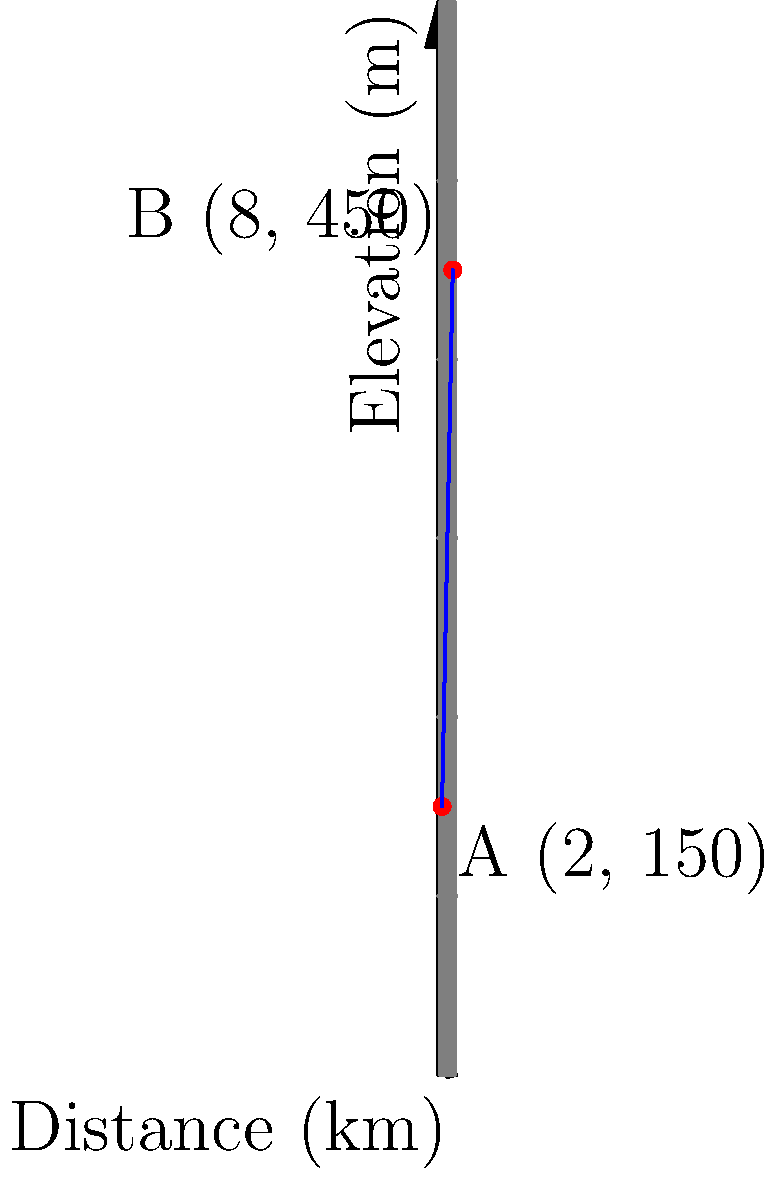During your creek hiking adventure in Nebraska, you come across a particularly challenging trail section. The trail starts at point A (2 km, 150 m) and ends at point B (8 km, 450 m), where the first coordinate represents the distance along the creek, and the second coordinate represents the elevation. What is the slope of this trail section? To find the slope of the trail section, we'll use the slope formula:

$$ \text{Slope} = \frac{\text{Change in y}}{\text{Change in x}} = \frac{y_2 - y_1}{x_2 - x_1} $$

Where $(x_1, y_1)$ is the starting point A, and $(x_2, y_2)$ is the ending point B.

Step 1: Identify the coordinates
Point A: $(x_1, y_1) = (2, 150)$
Point B: $(x_2, y_2) = (8, 450)$

Step 2: Calculate the change in y (elevation)
$\Delta y = y_2 - y_1 = 450 - 150 = 300$ meters

Step 3: Calculate the change in x (distance)
$\Delta x = x_2 - x_1 = 8 - 2 = 6$ kilometers

Step 4: Apply the slope formula
$$ \text{Slope} = \frac{\Delta y}{\Delta x} = \frac{300}{6} = 50 $$

Step 5: Interpret the result
The slope is 50 meters per kilometer, which means for every 1 kilometer of horizontal distance, the trail gains 50 meters in elevation.
Answer: 50 m/km 